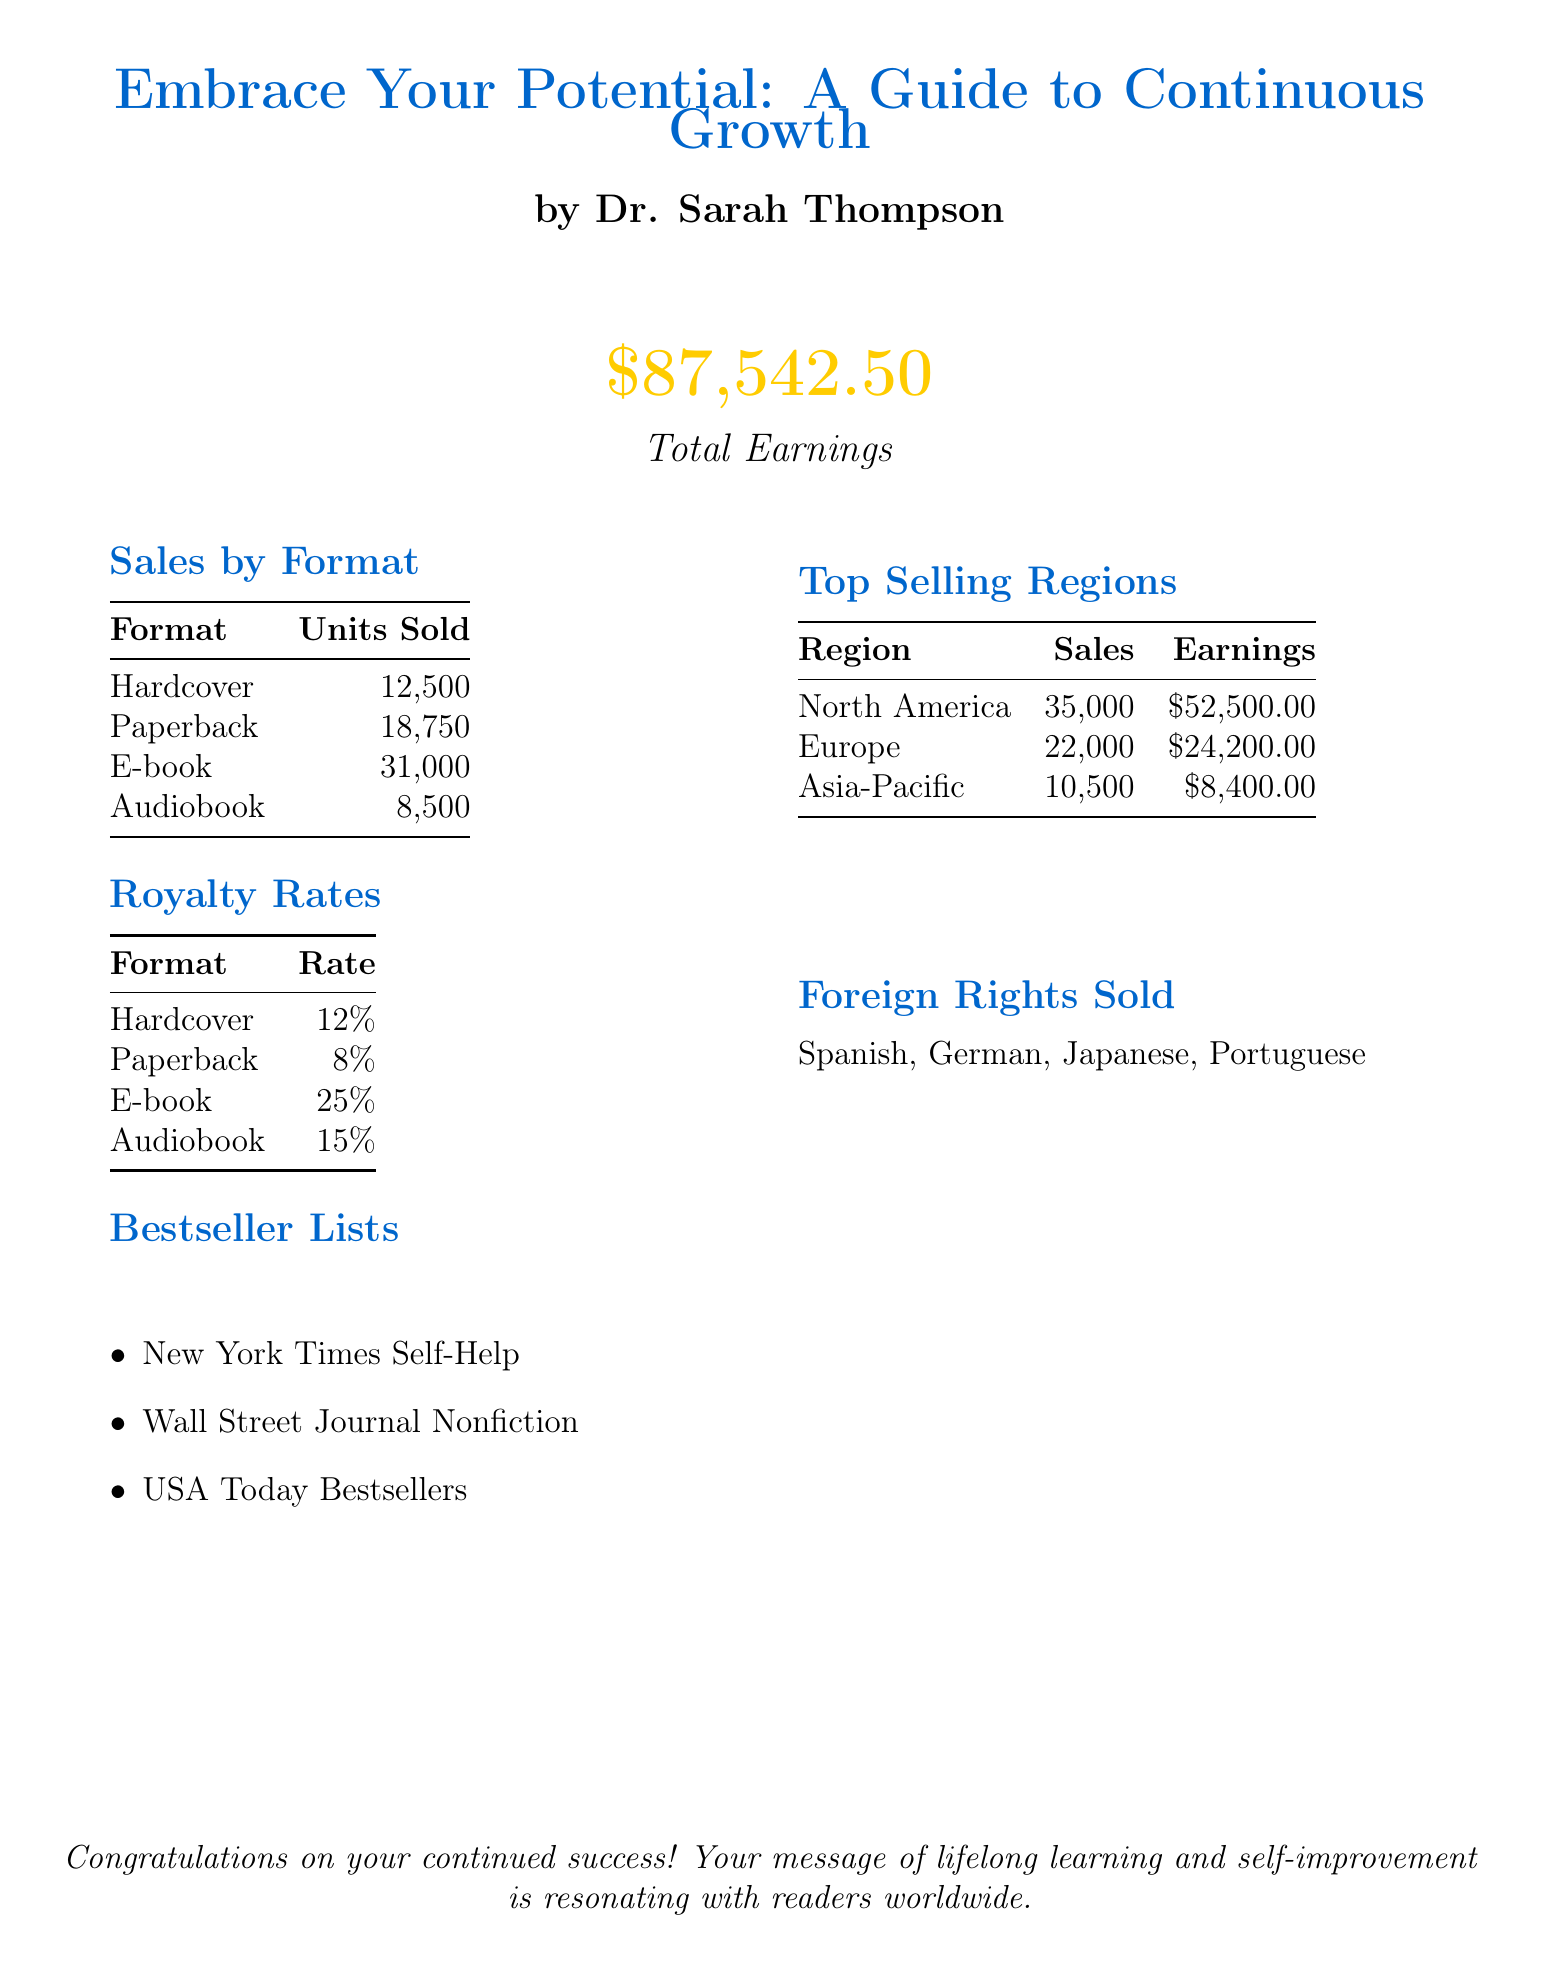What is the book title? The book title is clearly stated at the beginning of the document.
Answer: Embrace Your Potential: A Guide to Continuous Growth Who is the author? The author's name is mentioned alongside the book title.
Answer: Dr. Sarah Thompson What is the total earnings for the reporting period? Total earnings is summarized prominently in the document.
Answer: $87,542.50 How many e-books were sold? The sales figures by format indicate the number of e-books sold.
Answer: 31,000 Which region had the highest sales? The top selling regions section provides sales data for each region.
Answer: North America What is the royalty rate for audiobooks? The royalty rates section specifies the rate for audiobooks.
Answer: 15% How many bestseller lists is the book featured in? The bestseller lists section lists the different lists the book is featured in.
Answer: 3 What is the reporting period covered in this statement? The reporting period is mentioned in the header of the document.
Answer: January 1, 2023 - June 30, 2023 How many foreign rights were sold? The foreign rights sold section lists the languages, indicating the number sold.
Answer: 4 